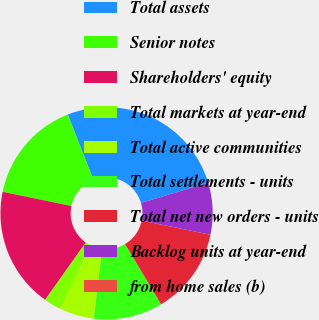<chart> <loc_0><loc_0><loc_500><loc_500><pie_chart><fcel>Total assets<fcel>Senior notes<fcel>Shareholders' equity<fcel>Total markets at year-end<fcel>Total active communities<fcel>Total settlements - units<fcel>Total net new orders - units<fcel>Backlog units at year-end<fcel>from home sales (b)<nl><fcel>26.32%<fcel>15.79%<fcel>18.42%<fcel>2.63%<fcel>5.26%<fcel>10.53%<fcel>13.16%<fcel>7.89%<fcel>0.0%<nl></chart> 